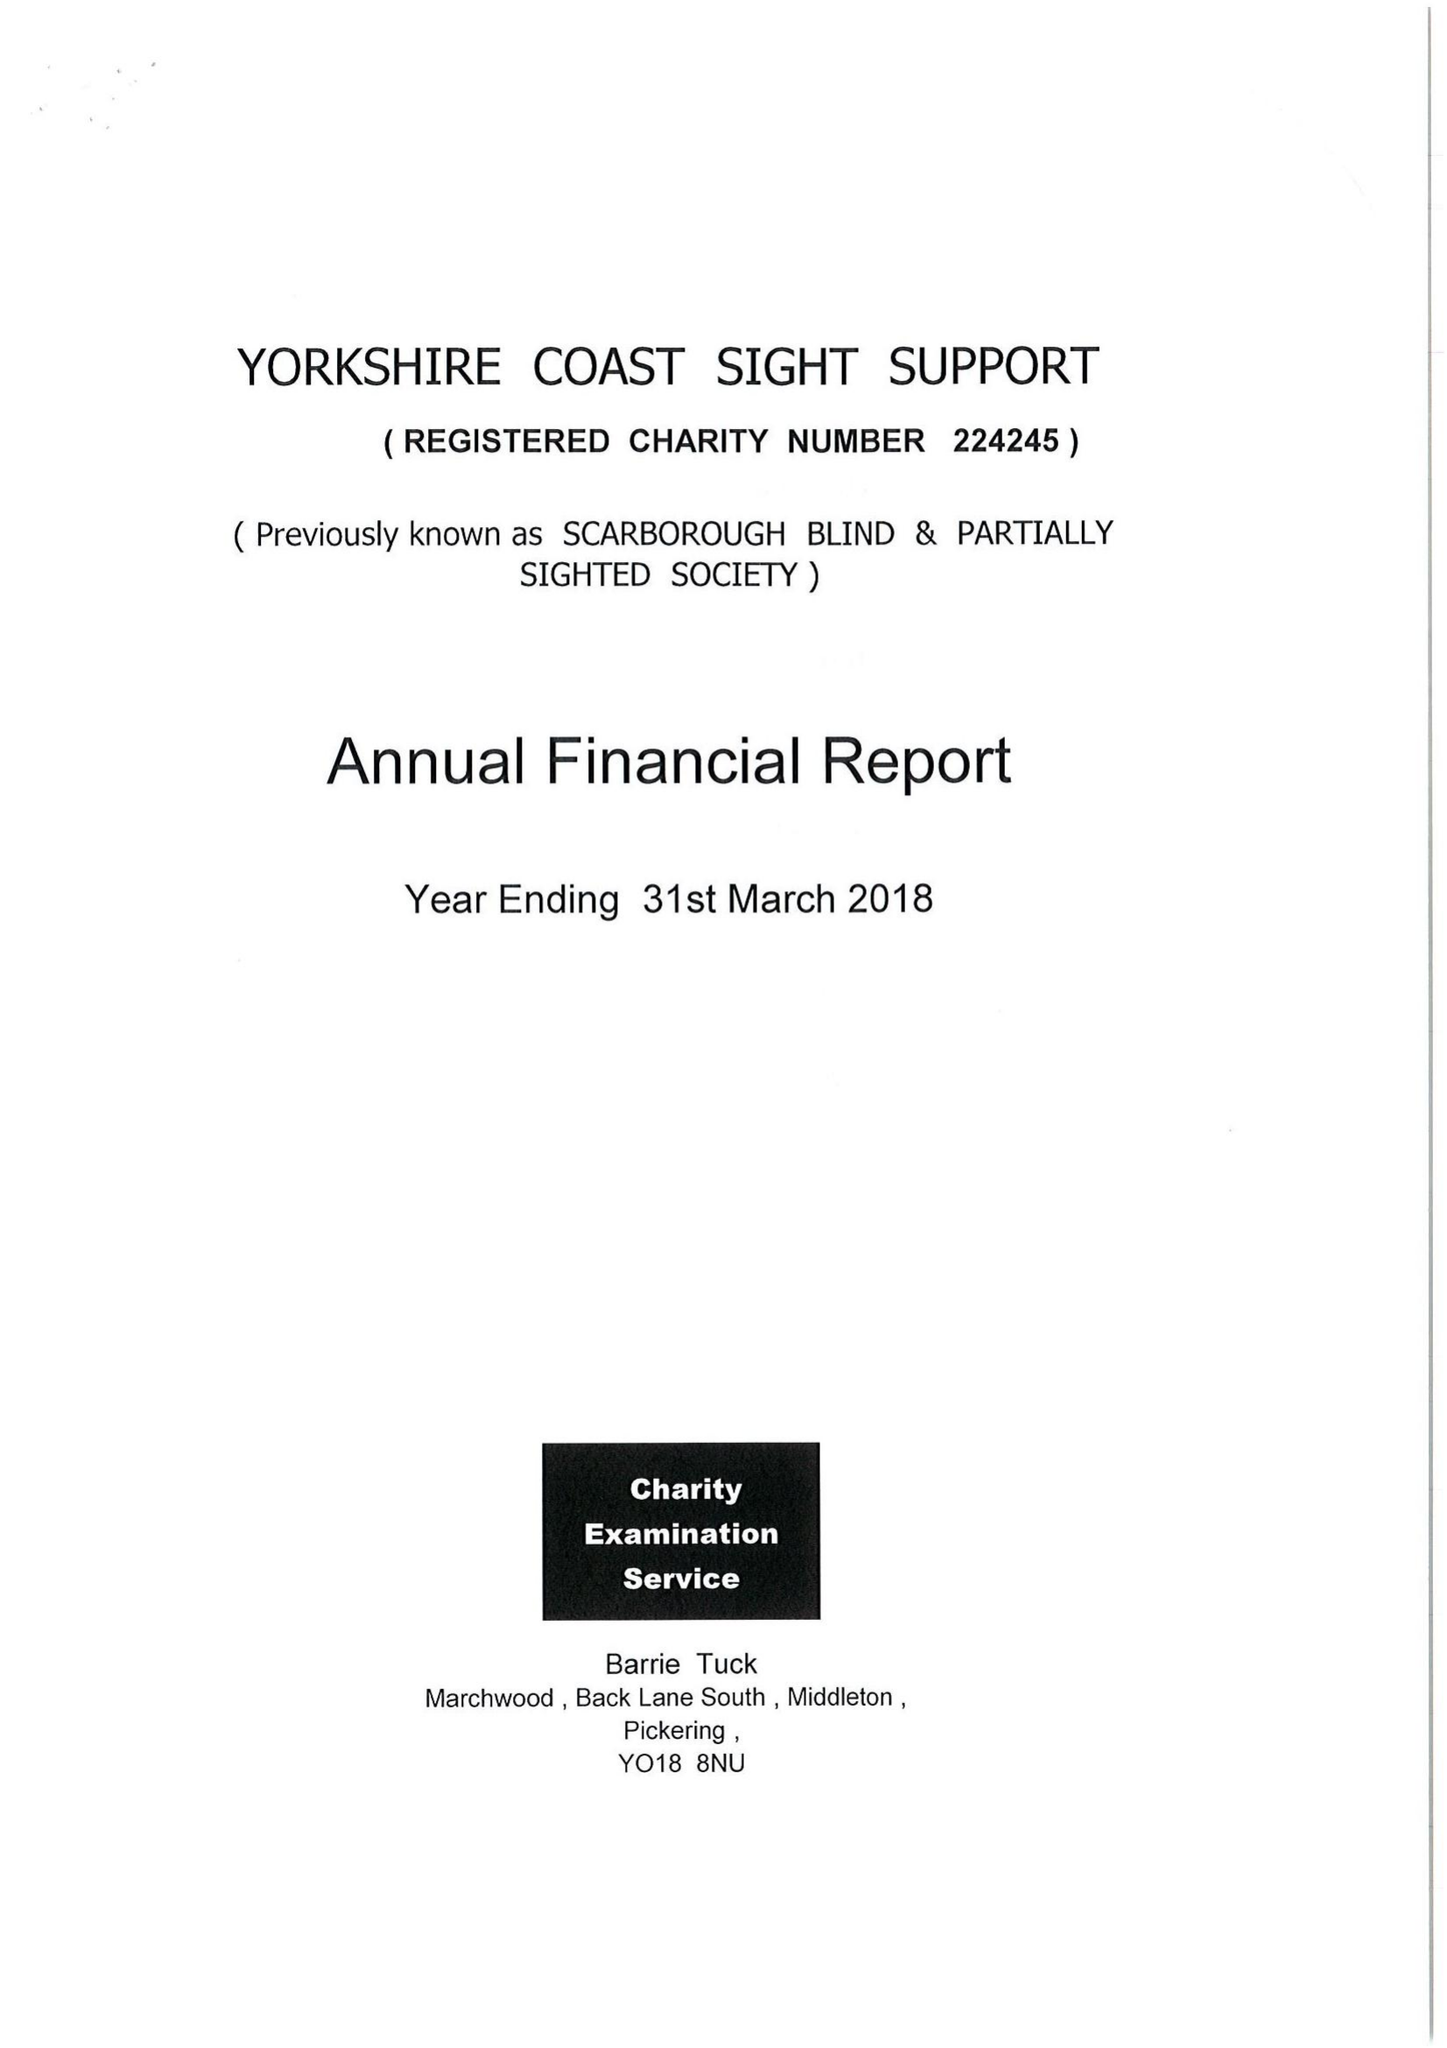What is the value for the address__street_line?
Answer the question using a single word or phrase. 181-183 DEAN ROAD 